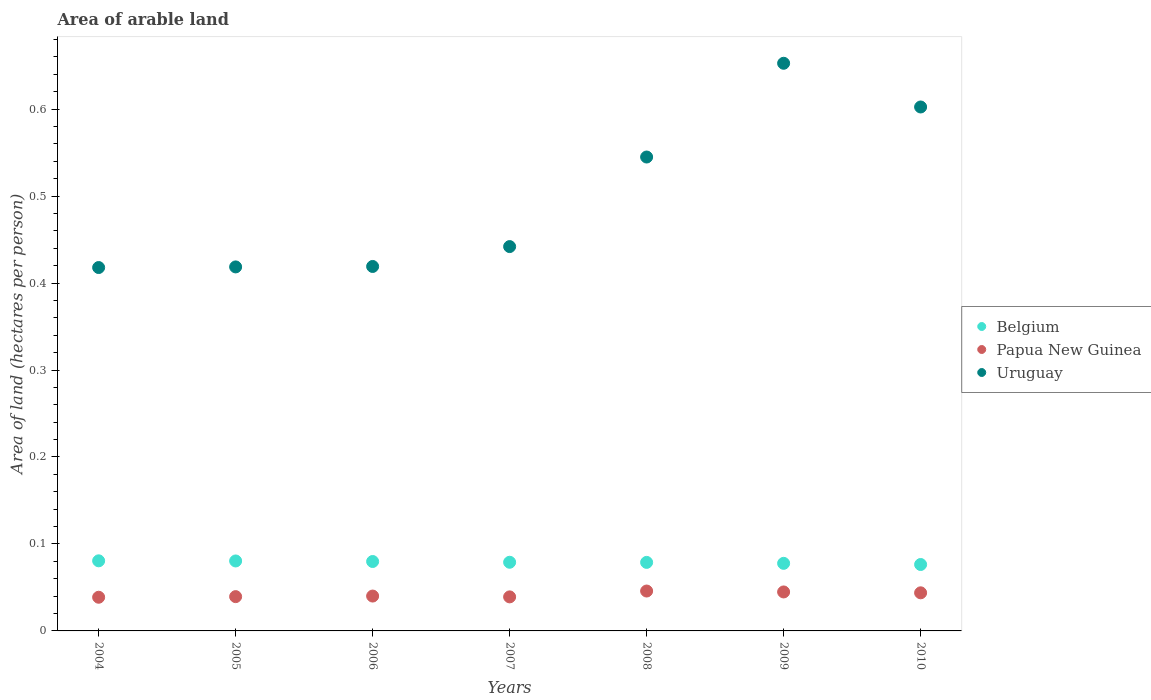How many different coloured dotlines are there?
Provide a short and direct response. 3. Is the number of dotlines equal to the number of legend labels?
Ensure brevity in your answer.  Yes. What is the total arable land in Uruguay in 2010?
Offer a terse response. 0.6. Across all years, what is the maximum total arable land in Uruguay?
Make the answer very short. 0.65. Across all years, what is the minimum total arable land in Belgium?
Your response must be concise. 0.08. In which year was the total arable land in Belgium maximum?
Provide a short and direct response. 2004. In which year was the total arable land in Papua New Guinea minimum?
Keep it short and to the point. 2004. What is the total total arable land in Uruguay in the graph?
Provide a succinct answer. 3.5. What is the difference between the total arable land in Papua New Guinea in 2008 and that in 2009?
Your answer should be compact. 0. What is the difference between the total arable land in Belgium in 2005 and the total arable land in Papua New Guinea in 2009?
Offer a terse response. 0.04. What is the average total arable land in Belgium per year?
Provide a short and direct response. 0.08. In the year 2008, what is the difference between the total arable land in Papua New Guinea and total arable land in Uruguay?
Keep it short and to the point. -0.5. In how many years, is the total arable land in Papua New Guinea greater than 0.08 hectares per person?
Your answer should be compact. 0. What is the ratio of the total arable land in Uruguay in 2005 to that in 2010?
Your response must be concise. 0.69. Is the total arable land in Uruguay in 2005 less than that in 2007?
Your answer should be very brief. Yes. What is the difference between the highest and the second highest total arable land in Papua New Guinea?
Your response must be concise. 0. What is the difference between the highest and the lowest total arable land in Uruguay?
Give a very brief answer. 0.23. In how many years, is the total arable land in Belgium greater than the average total arable land in Belgium taken over all years?
Make the answer very short. 3. Is the sum of the total arable land in Belgium in 2004 and 2007 greater than the maximum total arable land in Uruguay across all years?
Ensure brevity in your answer.  No. Does the total arable land in Uruguay monotonically increase over the years?
Keep it short and to the point. No. Is the total arable land in Belgium strictly less than the total arable land in Papua New Guinea over the years?
Provide a succinct answer. No. How many dotlines are there?
Your answer should be very brief. 3. What is the difference between two consecutive major ticks on the Y-axis?
Provide a short and direct response. 0.1. Are the values on the major ticks of Y-axis written in scientific E-notation?
Offer a terse response. No. Does the graph contain grids?
Make the answer very short. No. How many legend labels are there?
Make the answer very short. 3. What is the title of the graph?
Offer a terse response. Area of arable land. What is the label or title of the Y-axis?
Provide a succinct answer. Area of land (hectares per person). What is the Area of land (hectares per person) of Belgium in 2004?
Your response must be concise. 0.08. What is the Area of land (hectares per person) of Papua New Guinea in 2004?
Provide a succinct answer. 0.04. What is the Area of land (hectares per person) of Uruguay in 2004?
Your answer should be very brief. 0.42. What is the Area of land (hectares per person) in Belgium in 2005?
Provide a succinct answer. 0.08. What is the Area of land (hectares per person) of Papua New Guinea in 2005?
Make the answer very short. 0.04. What is the Area of land (hectares per person) of Uruguay in 2005?
Offer a very short reply. 0.42. What is the Area of land (hectares per person) of Belgium in 2006?
Offer a very short reply. 0.08. What is the Area of land (hectares per person) in Papua New Guinea in 2006?
Ensure brevity in your answer.  0.04. What is the Area of land (hectares per person) of Uruguay in 2006?
Make the answer very short. 0.42. What is the Area of land (hectares per person) of Belgium in 2007?
Provide a short and direct response. 0.08. What is the Area of land (hectares per person) in Papua New Guinea in 2007?
Your answer should be very brief. 0.04. What is the Area of land (hectares per person) of Uruguay in 2007?
Ensure brevity in your answer.  0.44. What is the Area of land (hectares per person) in Belgium in 2008?
Your answer should be very brief. 0.08. What is the Area of land (hectares per person) in Papua New Guinea in 2008?
Make the answer very short. 0.05. What is the Area of land (hectares per person) in Uruguay in 2008?
Offer a terse response. 0.54. What is the Area of land (hectares per person) in Belgium in 2009?
Your answer should be compact. 0.08. What is the Area of land (hectares per person) of Papua New Guinea in 2009?
Your answer should be very brief. 0.04. What is the Area of land (hectares per person) in Uruguay in 2009?
Ensure brevity in your answer.  0.65. What is the Area of land (hectares per person) of Belgium in 2010?
Your response must be concise. 0.08. What is the Area of land (hectares per person) in Papua New Guinea in 2010?
Make the answer very short. 0.04. What is the Area of land (hectares per person) in Uruguay in 2010?
Offer a very short reply. 0.6. Across all years, what is the maximum Area of land (hectares per person) in Belgium?
Make the answer very short. 0.08. Across all years, what is the maximum Area of land (hectares per person) of Papua New Guinea?
Provide a succinct answer. 0.05. Across all years, what is the maximum Area of land (hectares per person) of Uruguay?
Make the answer very short. 0.65. Across all years, what is the minimum Area of land (hectares per person) of Belgium?
Make the answer very short. 0.08. Across all years, what is the minimum Area of land (hectares per person) of Papua New Guinea?
Offer a terse response. 0.04. Across all years, what is the minimum Area of land (hectares per person) in Uruguay?
Make the answer very short. 0.42. What is the total Area of land (hectares per person) of Belgium in the graph?
Keep it short and to the point. 0.55. What is the total Area of land (hectares per person) of Papua New Guinea in the graph?
Your answer should be very brief. 0.29. What is the total Area of land (hectares per person) in Uruguay in the graph?
Your response must be concise. 3.5. What is the difference between the Area of land (hectares per person) of Belgium in 2004 and that in 2005?
Offer a terse response. 0. What is the difference between the Area of land (hectares per person) in Papua New Guinea in 2004 and that in 2005?
Offer a very short reply. -0. What is the difference between the Area of land (hectares per person) in Uruguay in 2004 and that in 2005?
Ensure brevity in your answer.  -0. What is the difference between the Area of land (hectares per person) in Belgium in 2004 and that in 2006?
Keep it short and to the point. 0. What is the difference between the Area of land (hectares per person) in Papua New Guinea in 2004 and that in 2006?
Provide a short and direct response. -0. What is the difference between the Area of land (hectares per person) in Uruguay in 2004 and that in 2006?
Give a very brief answer. -0. What is the difference between the Area of land (hectares per person) of Belgium in 2004 and that in 2007?
Provide a succinct answer. 0. What is the difference between the Area of land (hectares per person) of Papua New Guinea in 2004 and that in 2007?
Your answer should be very brief. -0. What is the difference between the Area of land (hectares per person) in Uruguay in 2004 and that in 2007?
Provide a succinct answer. -0.02. What is the difference between the Area of land (hectares per person) in Belgium in 2004 and that in 2008?
Keep it short and to the point. 0. What is the difference between the Area of land (hectares per person) in Papua New Guinea in 2004 and that in 2008?
Offer a terse response. -0.01. What is the difference between the Area of land (hectares per person) of Uruguay in 2004 and that in 2008?
Offer a terse response. -0.13. What is the difference between the Area of land (hectares per person) of Belgium in 2004 and that in 2009?
Offer a very short reply. 0. What is the difference between the Area of land (hectares per person) in Papua New Guinea in 2004 and that in 2009?
Your response must be concise. -0.01. What is the difference between the Area of land (hectares per person) in Uruguay in 2004 and that in 2009?
Offer a terse response. -0.23. What is the difference between the Area of land (hectares per person) in Belgium in 2004 and that in 2010?
Offer a terse response. 0. What is the difference between the Area of land (hectares per person) of Papua New Guinea in 2004 and that in 2010?
Offer a terse response. -0.01. What is the difference between the Area of land (hectares per person) of Uruguay in 2004 and that in 2010?
Provide a succinct answer. -0.18. What is the difference between the Area of land (hectares per person) in Belgium in 2005 and that in 2006?
Provide a succinct answer. 0. What is the difference between the Area of land (hectares per person) of Papua New Guinea in 2005 and that in 2006?
Your response must be concise. -0. What is the difference between the Area of land (hectares per person) of Uruguay in 2005 and that in 2006?
Your answer should be compact. -0. What is the difference between the Area of land (hectares per person) of Belgium in 2005 and that in 2007?
Your answer should be compact. 0. What is the difference between the Area of land (hectares per person) of Papua New Guinea in 2005 and that in 2007?
Offer a terse response. 0. What is the difference between the Area of land (hectares per person) of Uruguay in 2005 and that in 2007?
Offer a very short reply. -0.02. What is the difference between the Area of land (hectares per person) in Belgium in 2005 and that in 2008?
Your response must be concise. 0. What is the difference between the Area of land (hectares per person) in Papua New Guinea in 2005 and that in 2008?
Provide a short and direct response. -0.01. What is the difference between the Area of land (hectares per person) of Uruguay in 2005 and that in 2008?
Offer a terse response. -0.13. What is the difference between the Area of land (hectares per person) of Belgium in 2005 and that in 2009?
Offer a very short reply. 0. What is the difference between the Area of land (hectares per person) of Papua New Guinea in 2005 and that in 2009?
Make the answer very short. -0.01. What is the difference between the Area of land (hectares per person) in Uruguay in 2005 and that in 2009?
Provide a short and direct response. -0.23. What is the difference between the Area of land (hectares per person) of Belgium in 2005 and that in 2010?
Your answer should be very brief. 0. What is the difference between the Area of land (hectares per person) in Papua New Guinea in 2005 and that in 2010?
Make the answer very short. -0. What is the difference between the Area of land (hectares per person) of Uruguay in 2005 and that in 2010?
Your answer should be very brief. -0.18. What is the difference between the Area of land (hectares per person) of Belgium in 2006 and that in 2007?
Provide a succinct answer. 0. What is the difference between the Area of land (hectares per person) in Papua New Guinea in 2006 and that in 2007?
Provide a short and direct response. 0. What is the difference between the Area of land (hectares per person) in Uruguay in 2006 and that in 2007?
Provide a short and direct response. -0.02. What is the difference between the Area of land (hectares per person) in Papua New Guinea in 2006 and that in 2008?
Provide a short and direct response. -0.01. What is the difference between the Area of land (hectares per person) of Uruguay in 2006 and that in 2008?
Give a very brief answer. -0.13. What is the difference between the Area of land (hectares per person) in Belgium in 2006 and that in 2009?
Your answer should be very brief. 0. What is the difference between the Area of land (hectares per person) of Papua New Guinea in 2006 and that in 2009?
Your answer should be very brief. -0. What is the difference between the Area of land (hectares per person) of Uruguay in 2006 and that in 2009?
Provide a short and direct response. -0.23. What is the difference between the Area of land (hectares per person) of Belgium in 2006 and that in 2010?
Offer a very short reply. 0. What is the difference between the Area of land (hectares per person) of Papua New Guinea in 2006 and that in 2010?
Keep it short and to the point. -0. What is the difference between the Area of land (hectares per person) in Uruguay in 2006 and that in 2010?
Provide a succinct answer. -0.18. What is the difference between the Area of land (hectares per person) in Belgium in 2007 and that in 2008?
Keep it short and to the point. 0. What is the difference between the Area of land (hectares per person) in Papua New Guinea in 2007 and that in 2008?
Your answer should be very brief. -0.01. What is the difference between the Area of land (hectares per person) of Uruguay in 2007 and that in 2008?
Your answer should be very brief. -0.1. What is the difference between the Area of land (hectares per person) of Belgium in 2007 and that in 2009?
Give a very brief answer. 0. What is the difference between the Area of land (hectares per person) of Papua New Guinea in 2007 and that in 2009?
Provide a succinct answer. -0.01. What is the difference between the Area of land (hectares per person) of Uruguay in 2007 and that in 2009?
Keep it short and to the point. -0.21. What is the difference between the Area of land (hectares per person) of Belgium in 2007 and that in 2010?
Your answer should be compact. 0. What is the difference between the Area of land (hectares per person) in Papua New Guinea in 2007 and that in 2010?
Offer a very short reply. -0. What is the difference between the Area of land (hectares per person) in Uruguay in 2007 and that in 2010?
Provide a short and direct response. -0.16. What is the difference between the Area of land (hectares per person) of Belgium in 2008 and that in 2009?
Make the answer very short. 0. What is the difference between the Area of land (hectares per person) of Papua New Guinea in 2008 and that in 2009?
Ensure brevity in your answer.  0. What is the difference between the Area of land (hectares per person) of Uruguay in 2008 and that in 2009?
Your response must be concise. -0.11. What is the difference between the Area of land (hectares per person) of Belgium in 2008 and that in 2010?
Keep it short and to the point. 0. What is the difference between the Area of land (hectares per person) of Papua New Guinea in 2008 and that in 2010?
Keep it short and to the point. 0. What is the difference between the Area of land (hectares per person) in Uruguay in 2008 and that in 2010?
Offer a very short reply. -0.06. What is the difference between the Area of land (hectares per person) in Belgium in 2009 and that in 2010?
Make the answer very short. 0. What is the difference between the Area of land (hectares per person) in Papua New Guinea in 2009 and that in 2010?
Make the answer very short. 0. What is the difference between the Area of land (hectares per person) of Uruguay in 2009 and that in 2010?
Provide a succinct answer. 0.05. What is the difference between the Area of land (hectares per person) in Belgium in 2004 and the Area of land (hectares per person) in Papua New Guinea in 2005?
Ensure brevity in your answer.  0.04. What is the difference between the Area of land (hectares per person) of Belgium in 2004 and the Area of land (hectares per person) of Uruguay in 2005?
Offer a very short reply. -0.34. What is the difference between the Area of land (hectares per person) of Papua New Guinea in 2004 and the Area of land (hectares per person) of Uruguay in 2005?
Provide a succinct answer. -0.38. What is the difference between the Area of land (hectares per person) of Belgium in 2004 and the Area of land (hectares per person) of Papua New Guinea in 2006?
Your answer should be compact. 0.04. What is the difference between the Area of land (hectares per person) of Belgium in 2004 and the Area of land (hectares per person) of Uruguay in 2006?
Your response must be concise. -0.34. What is the difference between the Area of land (hectares per person) in Papua New Guinea in 2004 and the Area of land (hectares per person) in Uruguay in 2006?
Your answer should be very brief. -0.38. What is the difference between the Area of land (hectares per person) in Belgium in 2004 and the Area of land (hectares per person) in Papua New Guinea in 2007?
Your response must be concise. 0.04. What is the difference between the Area of land (hectares per person) of Belgium in 2004 and the Area of land (hectares per person) of Uruguay in 2007?
Make the answer very short. -0.36. What is the difference between the Area of land (hectares per person) of Papua New Guinea in 2004 and the Area of land (hectares per person) of Uruguay in 2007?
Make the answer very short. -0.4. What is the difference between the Area of land (hectares per person) of Belgium in 2004 and the Area of land (hectares per person) of Papua New Guinea in 2008?
Provide a succinct answer. 0.03. What is the difference between the Area of land (hectares per person) in Belgium in 2004 and the Area of land (hectares per person) in Uruguay in 2008?
Your answer should be compact. -0.46. What is the difference between the Area of land (hectares per person) in Papua New Guinea in 2004 and the Area of land (hectares per person) in Uruguay in 2008?
Ensure brevity in your answer.  -0.51. What is the difference between the Area of land (hectares per person) of Belgium in 2004 and the Area of land (hectares per person) of Papua New Guinea in 2009?
Offer a terse response. 0.04. What is the difference between the Area of land (hectares per person) of Belgium in 2004 and the Area of land (hectares per person) of Uruguay in 2009?
Ensure brevity in your answer.  -0.57. What is the difference between the Area of land (hectares per person) of Papua New Guinea in 2004 and the Area of land (hectares per person) of Uruguay in 2009?
Your answer should be very brief. -0.61. What is the difference between the Area of land (hectares per person) in Belgium in 2004 and the Area of land (hectares per person) in Papua New Guinea in 2010?
Your answer should be compact. 0.04. What is the difference between the Area of land (hectares per person) of Belgium in 2004 and the Area of land (hectares per person) of Uruguay in 2010?
Offer a very short reply. -0.52. What is the difference between the Area of land (hectares per person) of Papua New Guinea in 2004 and the Area of land (hectares per person) of Uruguay in 2010?
Your answer should be very brief. -0.56. What is the difference between the Area of land (hectares per person) of Belgium in 2005 and the Area of land (hectares per person) of Papua New Guinea in 2006?
Offer a very short reply. 0.04. What is the difference between the Area of land (hectares per person) of Belgium in 2005 and the Area of land (hectares per person) of Uruguay in 2006?
Ensure brevity in your answer.  -0.34. What is the difference between the Area of land (hectares per person) in Papua New Guinea in 2005 and the Area of land (hectares per person) in Uruguay in 2006?
Your answer should be very brief. -0.38. What is the difference between the Area of land (hectares per person) of Belgium in 2005 and the Area of land (hectares per person) of Papua New Guinea in 2007?
Give a very brief answer. 0.04. What is the difference between the Area of land (hectares per person) of Belgium in 2005 and the Area of land (hectares per person) of Uruguay in 2007?
Ensure brevity in your answer.  -0.36. What is the difference between the Area of land (hectares per person) of Papua New Guinea in 2005 and the Area of land (hectares per person) of Uruguay in 2007?
Your answer should be compact. -0.4. What is the difference between the Area of land (hectares per person) of Belgium in 2005 and the Area of land (hectares per person) of Papua New Guinea in 2008?
Your answer should be compact. 0.03. What is the difference between the Area of land (hectares per person) of Belgium in 2005 and the Area of land (hectares per person) of Uruguay in 2008?
Make the answer very short. -0.46. What is the difference between the Area of land (hectares per person) of Papua New Guinea in 2005 and the Area of land (hectares per person) of Uruguay in 2008?
Make the answer very short. -0.51. What is the difference between the Area of land (hectares per person) of Belgium in 2005 and the Area of land (hectares per person) of Papua New Guinea in 2009?
Keep it short and to the point. 0.04. What is the difference between the Area of land (hectares per person) in Belgium in 2005 and the Area of land (hectares per person) in Uruguay in 2009?
Ensure brevity in your answer.  -0.57. What is the difference between the Area of land (hectares per person) in Papua New Guinea in 2005 and the Area of land (hectares per person) in Uruguay in 2009?
Provide a short and direct response. -0.61. What is the difference between the Area of land (hectares per person) in Belgium in 2005 and the Area of land (hectares per person) in Papua New Guinea in 2010?
Ensure brevity in your answer.  0.04. What is the difference between the Area of land (hectares per person) in Belgium in 2005 and the Area of land (hectares per person) in Uruguay in 2010?
Keep it short and to the point. -0.52. What is the difference between the Area of land (hectares per person) in Papua New Guinea in 2005 and the Area of land (hectares per person) in Uruguay in 2010?
Offer a very short reply. -0.56. What is the difference between the Area of land (hectares per person) in Belgium in 2006 and the Area of land (hectares per person) in Papua New Guinea in 2007?
Offer a very short reply. 0.04. What is the difference between the Area of land (hectares per person) in Belgium in 2006 and the Area of land (hectares per person) in Uruguay in 2007?
Ensure brevity in your answer.  -0.36. What is the difference between the Area of land (hectares per person) of Papua New Guinea in 2006 and the Area of land (hectares per person) of Uruguay in 2007?
Provide a succinct answer. -0.4. What is the difference between the Area of land (hectares per person) of Belgium in 2006 and the Area of land (hectares per person) of Papua New Guinea in 2008?
Your answer should be very brief. 0.03. What is the difference between the Area of land (hectares per person) in Belgium in 2006 and the Area of land (hectares per person) in Uruguay in 2008?
Provide a short and direct response. -0.47. What is the difference between the Area of land (hectares per person) in Papua New Guinea in 2006 and the Area of land (hectares per person) in Uruguay in 2008?
Provide a short and direct response. -0.5. What is the difference between the Area of land (hectares per person) of Belgium in 2006 and the Area of land (hectares per person) of Papua New Guinea in 2009?
Your answer should be compact. 0.04. What is the difference between the Area of land (hectares per person) in Belgium in 2006 and the Area of land (hectares per person) in Uruguay in 2009?
Your answer should be compact. -0.57. What is the difference between the Area of land (hectares per person) in Papua New Guinea in 2006 and the Area of land (hectares per person) in Uruguay in 2009?
Give a very brief answer. -0.61. What is the difference between the Area of land (hectares per person) of Belgium in 2006 and the Area of land (hectares per person) of Papua New Guinea in 2010?
Provide a succinct answer. 0.04. What is the difference between the Area of land (hectares per person) of Belgium in 2006 and the Area of land (hectares per person) of Uruguay in 2010?
Provide a short and direct response. -0.52. What is the difference between the Area of land (hectares per person) of Papua New Guinea in 2006 and the Area of land (hectares per person) of Uruguay in 2010?
Keep it short and to the point. -0.56. What is the difference between the Area of land (hectares per person) of Belgium in 2007 and the Area of land (hectares per person) of Papua New Guinea in 2008?
Keep it short and to the point. 0.03. What is the difference between the Area of land (hectares per person) of Belgium in 2007 and the Area of land (hectares per person) of Uruguay in 2008?
Offer a very short reply. -0.47. What is the difference between the Area of land (hectares per person) of Papua New Guinea in 2007 and the Area of land (hectares per person) of Uruguay in 2008?
Your answer should be compact. -0.51. What is the difference between the Area of land (hectares per person) of Belgium in 2007 and the Area of land (hectares per person) of Papua New Guinea in 2009?
Offer a very short reply. 0.03. What is the difference between the Area of land (hectares per person) of Belgium in 2007 and the Area of land (hectares per person) of Uruguay in 2009?
Ensure brevity in your answer.  -0.57. What is the difference between the Area of land (hectares per person) in Papua New Guinea in 2007 and the Area of land (hectares per person) in Uruguay in 2009?
Provide a short and direct response. -0.61. What is the difference between the Area of land (hectares per person) of Belgium in 2007 and the Area of land (hectares per person) of Papua New Guinea in 2010?
Give a very brief answer. 0.04. What is the difference between the Area of land (hectares per person) of Belgium in 2007 and the Area of land (hectares per person) of Uruguay in 2010?
Keep it short and to the point. -0.52. What is the difference between the Area of land (hectares per person) of Papua New Guinea in 2007 and the Area of land (hectares per person) of Uruguay in 2010?
Keep it short and to the point. -0.56. What is the difference between the Area of land (hectares per person) of Belgium in 2008 and the Area of land (hectares per person) of Papua New Guinea in 2009?
Offer a terse response. 0.03. What is the difference between the Area of land (hectares per person) in Belgium in 2008 and the Area of land (hectares per person) in Uruguay in 2009?
Your response must be concise. -0.57. What is the difference between the Area of land (hectares per person) in Papua New Guinea in 2008 and the Area of land (hectares per person) in Uruguay in 2009?
Give a very brief answer. -0.61. What is the difference between the Area of land (hectares per person) in Belgium in 2008 and the Area of land (hectares per person) in Papua New Guinea in 2010?
Offer a very short reply. 0.04. What is the difference between the Area of land (hectares per person) of Belgium in 2008 and the Area of land (hectares per person) of Uruguay in 2010?
Offer a very short reply. -0.52. What is the difference between the Area of land (hectares per person) in Papua New Guinea in 2008 and the Area of land (hectares per person) in Uruguay in 2010?
Your response must be concise. -0.56. What is the difference between the Area of land (hectares per person) in Belgium in 2009 and the Area of land (hectares per person) in Papua New Guinea in 2010?
Your response must be concise. 0.03. What is the difference between the Area of land (hectares per person) of Belgium in 2009 and the Area of land (hectares per person) of Uruguay in 2010?
Ensure brevity in your answer.  -0.52. What is the difference between the Area of land (hectares per person) of Papua New Guinea in 2009 and the Area of land (hectares per person) of Uruguay in 2010?
Your answer should be compact. -0.56. What is the average Area of land (hectares per person) in Belgium per year?
Give a very brief answer. 0.08. What is the average Area of land (hectares per person) of Papua New Guinea per year?
Provide a succinct answer. 0.04. What is the average Area of land (hectares per person) in Uruguay per year?
Offer a terse response. 0.5. In the year 2004, what is the difference between the Area of land (hectares per person) of Belgium and Area of land (hectares per person) of Papua New Guinea?
Make the answer very short. 0.04. In the year 2004, what is the difference between the Area of land (hectares per person) of Belgium and Area of land (hectares per person) of Uruguay?
Provide a short and direct response. -0.34. In the year 2004, what is the difference between the Area of land (hectares per person) in Papua New Guinea and Area of land (hectares per person) in Uruguay?
Ensure brevity in your answer.  -0.38. In the year 2005, what is the difference between the Area of land (hectares per person) in Belgium and Area of land (hectares per person) in Papua New Guinea?
Your answer should be compact. 0.04. In the year 2005, what is the difference between the Area of land (hectares per person) in Belgium and Area of land (hectares per person) in Uruguay?
Provide a short and direct response. -0.34. In the year 2005, what is the difference between the Area of land (hectares per person) in Papua New Guinea and Area of land (hectares per person) in Uruguay?
Your response must be concise. -0.38. In the year 2006, what is the difference between the Area of land (hectares per person) of Belgium and Area of land (hectares per person) of Papua New Guinea?
Offer a very short reply. 0.04. In the year 2006, what is the difference between the Area of land (hectares per person) of Belgium and Area of land (hectares per person) of Uruguay?
Your answer should be very brief. -0.34. In the year 2006, what is the difference between the Area of land (hectares per person) in Papua New Guinea and Area of land (hectares per person) in Uruguay?
Give a very brief answer. -0.38. In the year 2007, what is the difference between the Area of land (hectares per person) in Belgium and Area of land (hectares per person) in Papua New Guinea?
Your answer should be very brief. 0.04. In the year 2007, what is the difference between the Area of land (hectares per person) of Belgium and Area of land (hectares per person) of Uruguay?
Your answer should be very brief. -0.36. In the year 2007, what is the difference between the Area of land (hectares per person) in Papua New Guinea and Area of land (hectares per person) in Uruguay?
Your answer should be very brief. -0.4. In the year 2008, what is the difference between the Area of land (hectares per person) in Belgium and Area of land (hectares per person) in Papua New Guinea?
Provide a short and direct response. 0.03. In the year 2008, what is the difference between the Area of land (hectares per person) of Belgium and Area of land (hectares per person) of Uruguay?
Your response must be concise. -0.47. In the year 2008, what is the difference between the Area of land (hectares per person) in Papua New Guinea and Area of land (hectares per person) in Uruguay?
Provide a short and direct response. -0.5. In the year 2009, what is the difference between the Area of land (hectares per person) of Belgium and Area of land (hectares per person) of Papua New Guinea?
Your response must be concise. 0.03. In the year 2009, what is the difference between the Area of land (hectares per person) in Belgium and Area of land (hectares per person) in Uruguay?
Offer a very short reply. -0.57. In the year 2009, what is the difference between the Area of land (hectares per person) in Papua New Guinea and Area of land (hectares per person) in Uruguay?
Your response must be concise. -0.61. In the year 2010, what is the difference between the Area of land (hectares per person) of Belgium and Area of land (hectares per person) of Papua New Guinea?
Give a very brief answer. 0.03. In the year 2010, what is the difference between the Area of land (hectares per person) of Belgium and Area of land (hectares per person) of Uruguay?
Give a very brief answer. -0.53. In the year 2010, what is the difference between the Area of land (hectares per person) of Papua New Guinea and Area of land (hectares per person) of Uruguay?
Make the answer very short. -0.56. What is the ratio of the Area of land (hectares per person) of Belgium in 2004 to that in 2005?
Your answer should be very brief. 1. What is the ratio of the Area of land (hectares per person) of Papua New Guinea in 2004 to that in 2005?
Your response must be concise. 0.98. What is the ratio of the Area of land (hectares per person) of Uruguay in 2004 to that in 2005?
Offer a terse response. 1. What is the ratio of the Area of land (hectares per person) of Belgium in 2004 to that in 2006?
Your response must be concise. 1.01. What is the ratio of the Area of land (hectares per person) of Papua New Guinea in 2004 to that in 2006?
Make the answer very short. 0.97. What is the ratio of the Area of land (hectares per person) of Belgium in 2004 to that in 2007?
Your response must be concise. 1.02. What is the ratio of the Area of land (hectares per person) in Papua New Guinea in 2004 to that in 2007?
Keep it short and to the point. 0.99. What is the ratio of the Area of land (hectares per person) in Uruguay in 2004 to that in 2007?
Keep it short and to the point. 0.95. What is the ratio of the Area of land (hectares per person) in Belgium in 2004 to that in 2008?
Keep it short and to the point. 1.02. What is the ratio of the Area of land (hectares per person) of Papua New Guinea in 2004 to that in 2008?
Keep it short and to the point. 0.84. What is the ratio of the Area of land (hectares per person) in Uruguay in 2004 to that in 2008?
Your response must be concise. 0.77. What is the ratio of the Area of land (hectares per person) of Belgium in 2004 to that in 2009?
Ensure brevity in your answer.  1.04. What is the ratio of the Area of land (hectares per person) in Papua New Guinea in 2004 to that in 2009?
Make the answer very short. 0.86. What is the ratio of the Area of land (hectares per person) of Uruguay in 2004 to that in 2009?
Give a very brief answer. 0.64. What is the ratio of the Area of land (hectares per person) of Belgium in 2004 to that in 2010?
Provide a short and direct response. 1.06. What is the ratio of the Area of land (hectares per person) in Papua New Guinea in 2004 to that in 2010?
Your response must be concise. 0.88. What is the ratio of the Area of land (hectares per person) in Uruguay in 2004 to that in 2010?
Give a very brief answer. 0.69. What is the ratio of the Area of land (hectares per person) of Belgium in 2005 to that in 2006?
Provide a succinct answer. 1.01. What is the ratio of the Area of land (hectares per person) in Papua New Guinea in 2005 to that in 2006?
Offer a terse response. 0.98. What is the ratio of the Area of land (hectares per person) in Belgium in 2005 to that in 2007?
Keep it short and to the point. 1.02. What is the ratio of the Area of land (hectares per person) in Papua New Guinea in 2005 to that in 2007?
Offer a very short reply. 1.01. What is the ratio of the Area of land (hectares per person) in Uruguay in 2005 to that in 2007?
Give a very brief answer. 0.95. What is the ratio of the Area of land (hectares per person) in Belgium in 2005 to that in 2008?
Offer a terse response. 1.02. What is the ratio of the Area of land (hectares per person) of Papua New Guinea in 2005 to that in 2008?
Provide a succinct answer. 0.86. What is the ratio of the Area of land (hectares per person) of Uruguay in 2005 to that in 2008?
Provide a succinct answer. 0.77. What is the ratio of the Area of land (hectares per person) in Belgium in 2005 to that in 2009?
Give a very brief answer. 1.04. What is the ratio of the Area of land (hectares per person) in Papua New Guinea in 2005 to that in 2009?
Make the answer very short. 0.88. What is the ratio of the Area of land (hectares per person) in Uruguay in 2005 to that in 2009?
Provide a succinct answer. 0.64. What is the ratio of the Area of land (hectares per person) of Belgium in 2005 to that in 2010?
Ensure brevity in your answer.  1.05. What is the ratio of the Area of land (hectares per person) in Uruguay in 2005 to that in 2010?
Ensure brevity in your answer.  0.69. What is the ratio of the Area of land (hectares per person) of Papua New Guinea in 2006 to that in 2007?
Your response must be concise. 1.02. What is the ratio of the Area of land (hectares per person) of Uruguay in 2006 to that in 2007?
Make the answer very short. 0.95. What is the ratio of the Area of land (hectares per person) in Belgium in 2006 to that in 2008?
Your answer should be compact. 1.01. What is the ratio of the Area of land (hectares per person) in Papua New Guinea in 2006 to that in 2008?
Offer a very short reply. 0.87. What is the ratio of the Area of land (hectares per person) in Uruguay in 2006 to that in 2008?
Offer a terse response. 0.77. What is the ratio of the Area of land (hectares per person) in Belgium in 2006 to that in 2009?
Offer a terse response. 1.03. What is the ratio of the Area of land (hectares per person) of Papua New Guinea in 2006 to that in 2009?
Your response must be concise. 0.89. What is the ratio of the Area of land (hectares per person) of Uruguay in 2006 to that in 2009?
Give a very brief answer. 0.64. What is the ratio of the Area of land (hectares per person) in Belgium in 2006 to that in 2010?
Your response must be concise. 1.05. What is the ratio of the Area of land (hectares per person) in Papua New Guinea in 2006 to that in 2010?
Offer a very short reply. 0.92. What is the ratio of the Area of land (hectares per person) in Uruguay in 2006 to that in 2010?
Ensure brevity in your answer.  0.7. What is the ratio of the Area of land (hectares per person) of Papua New Guinea in 2007 to that in 2008?
Offer a terse response. 0.85. What is the ratio of the Area of land (hectares per person) of Uruguay in 2007 to that in 2008?
Your response must be concise. 0.81. What is the ratio of the Area of land (hectares per person) of Belgium in 2007 to that in 2009?
Your answer should be compact. 1.02. What is the ratio of the Area of land (hectares per person) of Papua New Guinea in 2007 to that in 2009?
Offer a terse response. 0.87. What is the ratio of the Area of land (hectares per person) in Uruguay in 2007 to that in 2009?
Provide a short and direct response. 0.68. What is the ratio of the Area of land (hectares per person) in Belgium in 2007 to that in 2010?
Offer a very short reply. 1.03. What is the ratio of the Area of land (hectares per person) of Papua New Guinea in 2007 to that in 2010?
Provide a succinct answer. 0.89. What is the ratio of the Area of land (hectares per person) in Uruguay in 2007 to that in 2010?
Keep it short and to the point. 0.73. What is the ratio of the Area of land (hectares per person) of Belgium in 2008 to that in 2009?
Provide a short and direct response. 1.01. What is the ratio of the Area of land (hectares per person) of Papua New Guinea in 2008 to that in 2009?
Ensure brevity in your answer.  1.02. What is the ratio of the Area of land (hectares per person) in Uruguay in 2008 to that in 2009?
Your answer should be compact. 0.83. What is the ratio of the Area of land (hectares per person) of Belgium in 2008 to that in 2010?
Your answer should be very brief. 1.03. What is the ratio of the Area of land (hectares per person) in Papua New Guinea in 2008 to that in 2010?
Offer a terse response. 1.05. What is the ratio of the Area of land (hectares per person) in Uruguay in 2008 to that in 2010?
Offer a terse response. 0.9. What is the ratio of the Area of land (hectares per person) in Belgium in 2009 to that in 2010?
Your response must be concise. 1.02. What is the ratio of the Area of land (hectares per person) of Uruguay in 2009 to that in 2010?
Your response must be concise. 1.08. What is the difference between the highest and the second highest Area of land (hectares per person) in Belgium?
Your answer should be very brief. 0. What is the difference between the highest and the second highest Area of land (hectares per person) of Papua New Guinea?
Your response must be concise. 0. What is the difference between the highest and the second highest Area of land (hectares per person) in Uruguay?
Make the answer very short. 0.05. What is the difference between the highest and the lowest Area of land (hectares per person) of Belgium?
Offer a very short reply. 0. What is the difference between the highest and the lowest Area of land (hectares per person) of Papua New Guinea?
Your answer should be compact. 0.01. What is the difference between the highest and the lowest Area of land (hectares per person) in Uruguay?
Provide a succinct answer. 0.23. 